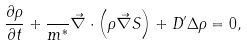Convert formula to latex. <formula><loc_0><loc_0><loc_500><loc_500>\frac { \partial \rho } { \partial t } + \frac { } { m ^ { * } } \vec { \nabla } \cdot \left ( \rho \vec { \nabla } S \right ) + D ^ { \prime } \Delta \rho = 0 ,</formula> 